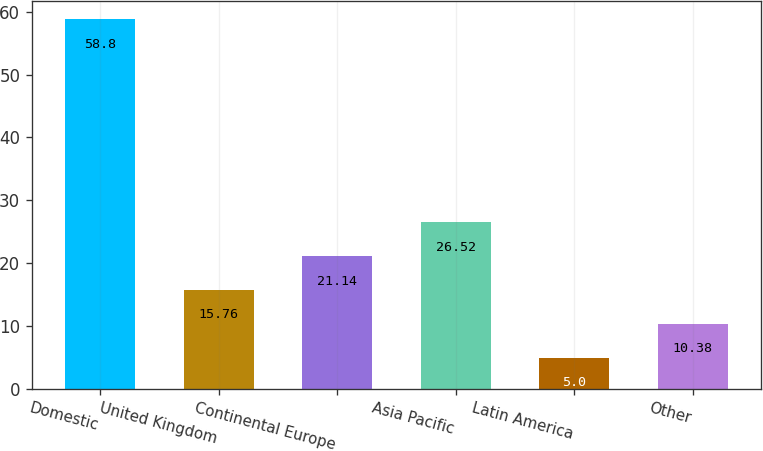Convert chart to OTSL. <chart><loc_0><loc_0><loc_500><loc_500><bar_chart><fcel>Domestic<fcel>United Kingdom<fcel>Continental Europe<fcel>Asia Pacific<fcel>Latin America<fcel>Other<nl><fcel>58.8<fcel>15.76<fcel>21.14<fcel>26.52<fcel>5<fcel>10.38<nl></chart> 